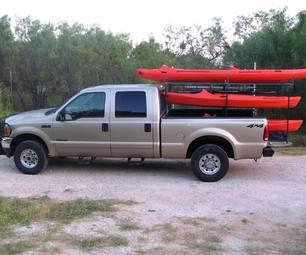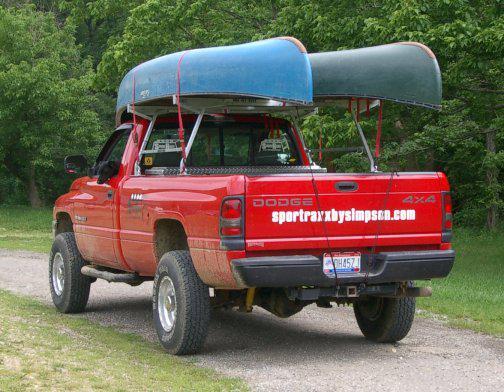The first image is the image on the left, the second image is the image on the right. Assess this claim about the two images: "A pickup carrying two different colored canoes is heading away from the camera, in one image.". Correct or not? Answer yes or no. Yes. 